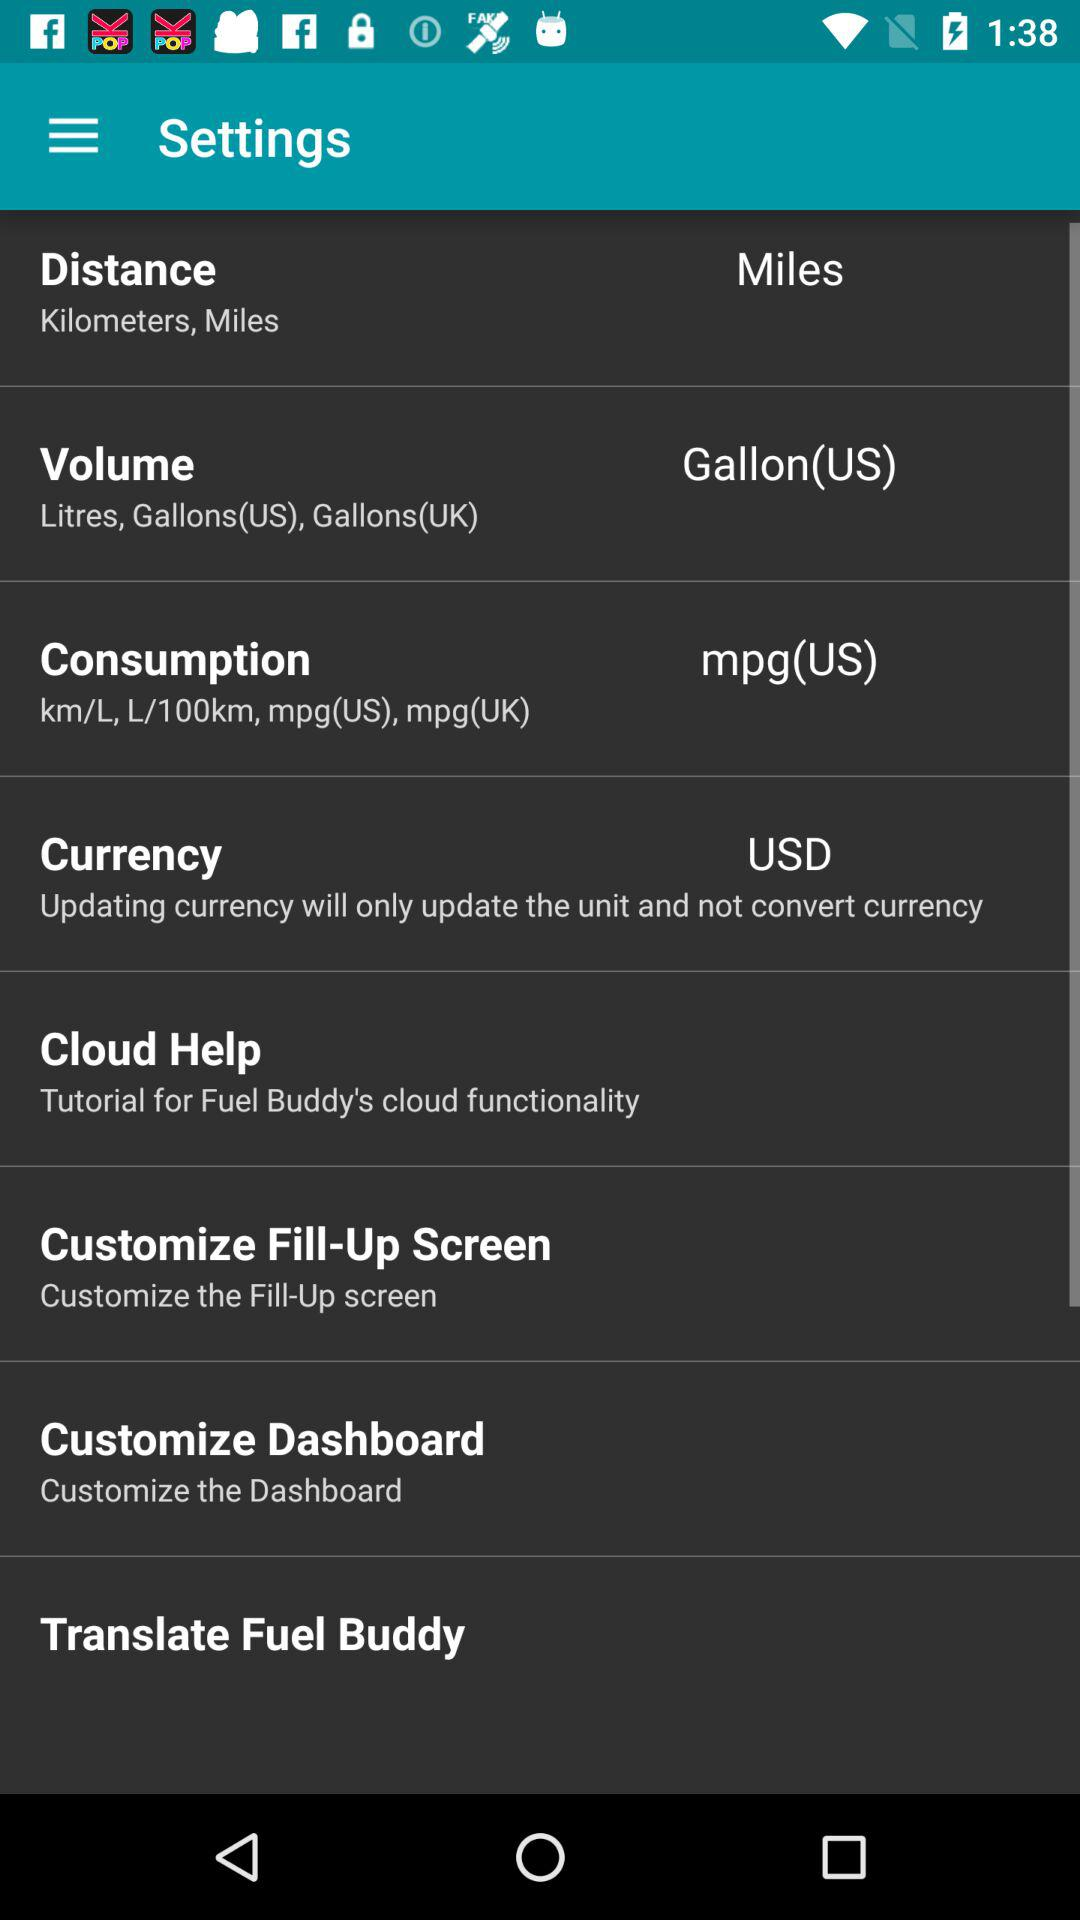What is the chosen unit of consumption? The chosen unit of consumption is mpg (US). 